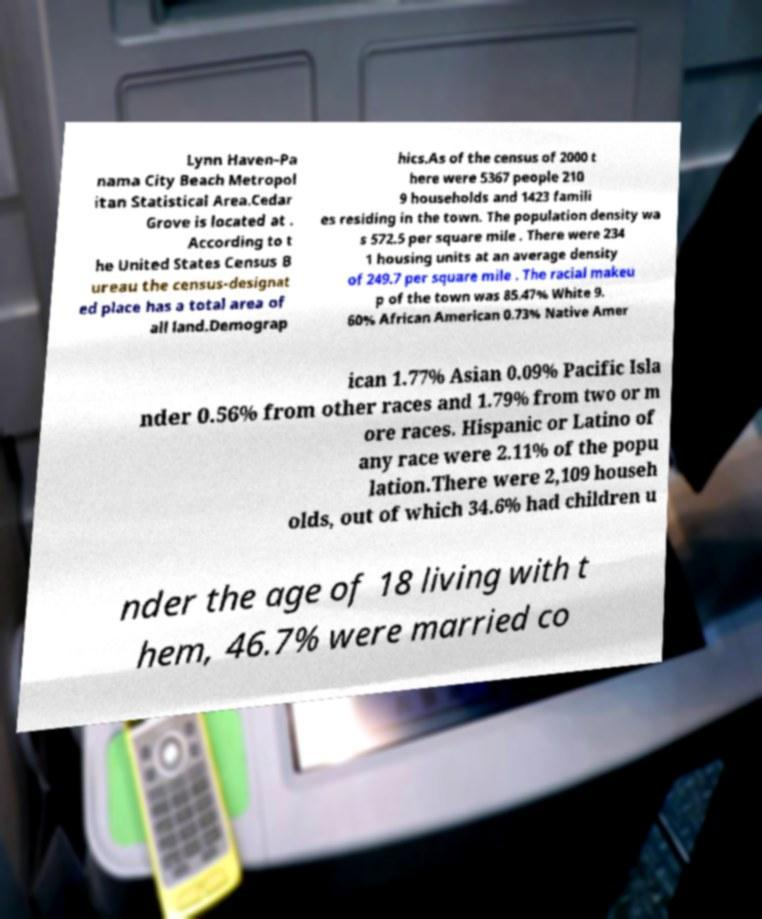There's text embedded in this image that I need extracted. Can you transcribe it verbatim? Lynn Haven–Pa nama City Beach Metropol itan Statistical Area.Cedar Grove is located at . According to t he United States Census B ureau the census-designat ed place has a total area of all land.Demograp hics.As of the census of 2000 t here were 5367 people 210 9 households and 1423 famili es residing in the town. The population density wa s 572.5 per square mile . There were 234 1 housing units at an average density of 249.7 per square mile . The racial makeu p of the town was 85.47% White 9. 60% African American 0.73% Native Amer ican 1.77% Asian 0.09% Pacific Isla nder 0.56% from other races and 1.79% from two or m ore races. Hispanic or Latino of any race were 2.11% of the popu lation.There were 2,109 househ olds, out of which 34.6% had children u nder the age of 18 living with t hem, 46.7% were married co 